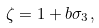Convert formula to latex. <formula><loc_0><loc_0><loc_500><loc_500>\zeta = 1 + b \sigma _ { 3 } ,</formula> 